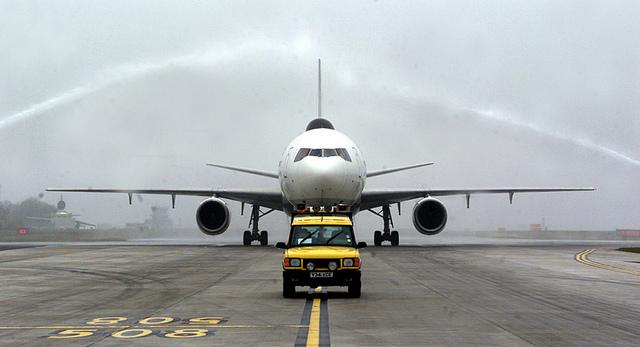What color is the line on the pavement?
Concise answer only. Yellow. What color is the truck?
Write a very short answer. Yellow. Why is there a car right in front of a plane?
Short answer required. Safety vehicle. 